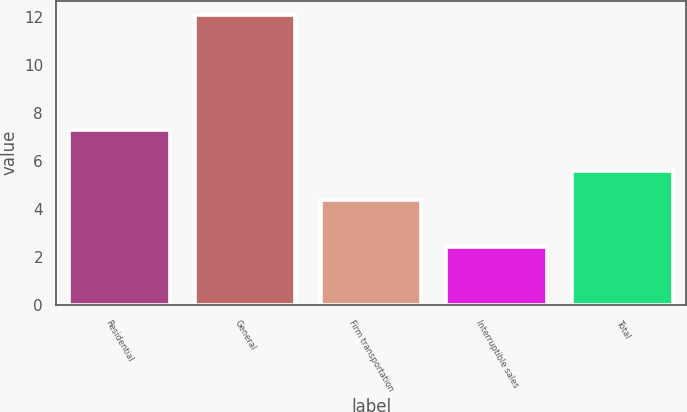Convert chart to OTSL. <chart><loc_0><loc_0><loc_500><loc_500><bar_chart><fcel>Residential<fcel>General<fcel>Firm transportation<fcel>Interruptible sales<fcel>Total<nl><fcel>7.3<fcel>12.1<fcel>4.4<fcel>2.4<fcel>5.6<nl></chart> 